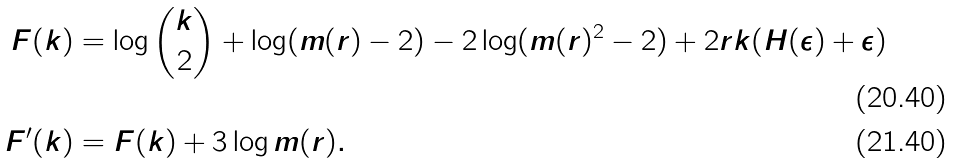<formula> <loc_0><loc_0><loc_500><loc_500>F ( k ) & = \log { k \choose 2 } + \log ( m ( r ) - 2 ) - 2 \log ( m ( r ) ^ { 2 } - 2 ) + 2 r k ( H ( \epsilon ) + \epsilon ) \\ F ^ { \prime } ( k ) & = F ( k ) + 3 \log m ( r ) .</formula> 